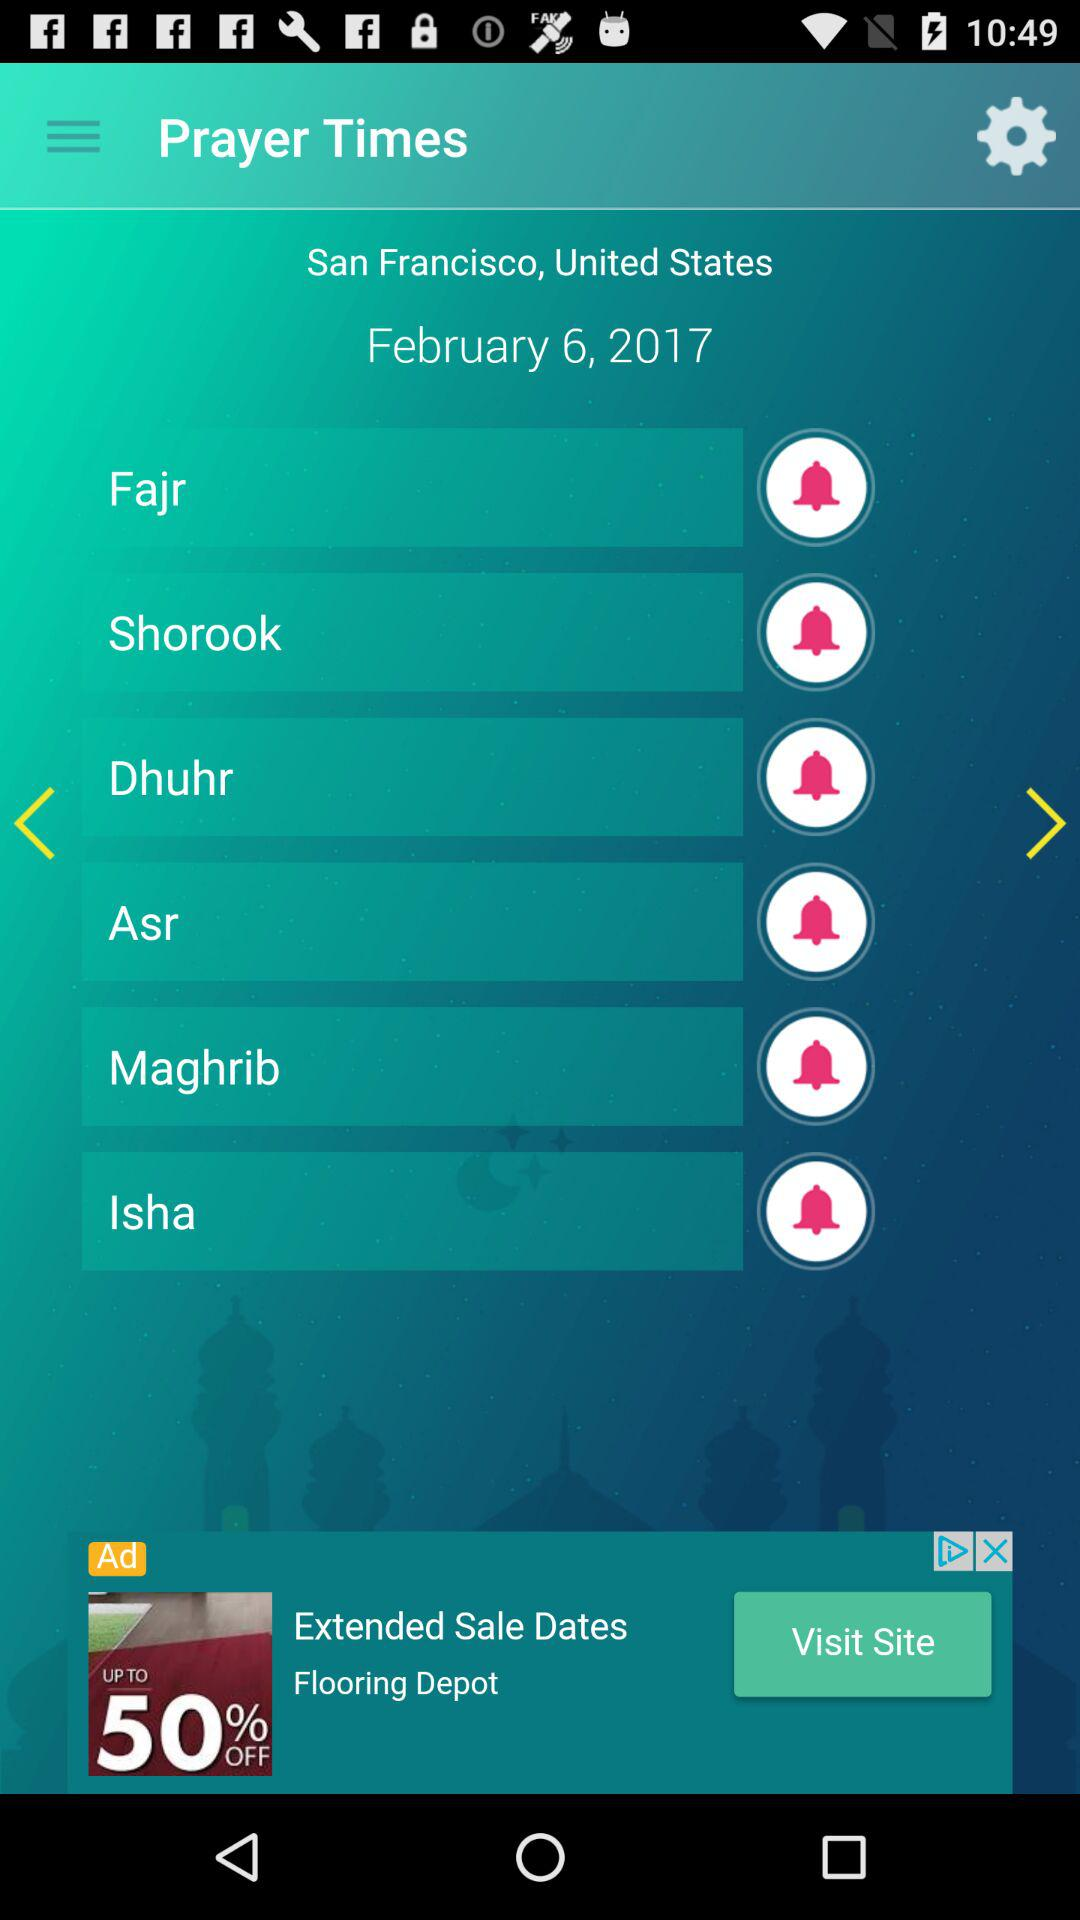What is the location? The location is San Francisco, United States. 